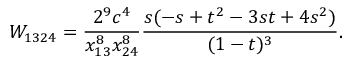Convert formula to latex. <formula><loc_0><loc_0><loc_500><loc_500>W _ { 1 3 2 4 } = \frac { 2 ^ { 9 } c ^ { 4 } } { x _ { 1 3 } ^ { 8 } x _ { 2 4 } ^ { 8 } } \frac { s ( - s + t ^ { 2 } - 3 s t + 4 s ^ { 2 } ) } { ( 1 - t ) ^ { 3 } } .</formula> 